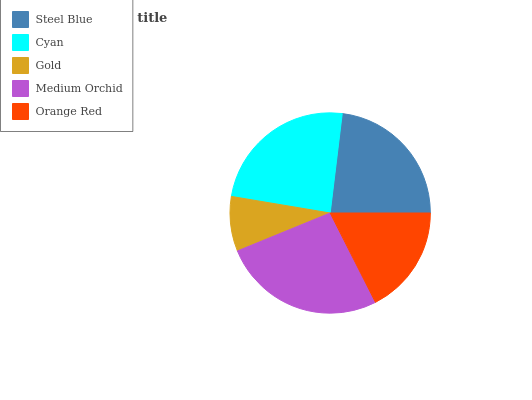Is Gold the minimum?
Answer yes or no. Yes. Is Medium Orchid the maximum?
Answer yes or no. Yes. Is Cyan the minimum?
Answer yes or no. No. Is Cyan the maximum?
Answer yes or no. No. Is Cyan greater than Steel Blue?
Answer yes or no. Yes. Is Steel Blue less than Cyan?
Answer yes or no. Yes. Is Steel Blue greater than Cyan?
Answer yes or no. No. Is Cyan less than Steel Blue?
Answer yes or no. No. Is Steel Blue the high median?
Answer yes or no. Yes. Is Steel Blue the low median?
Answer yes or no. Yes. Is Orange Red the high median?
Answer yes or no. No. Is Medium Orchid the low median?
Answer yes or no. No. 